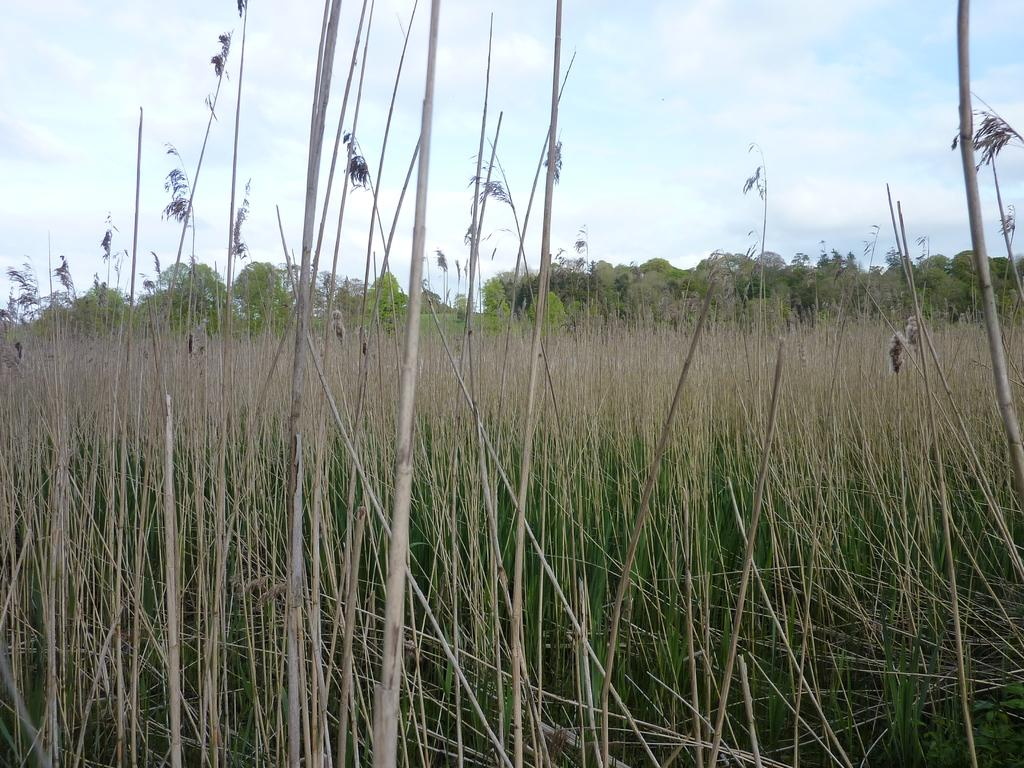What can be seen at the top of the image? The sky is visible towards the top of the image. What is present in the sky? There are clouds in the sky. What type of vegetation is present in the image? There are trees and plants in the image. Where are the plants located in the image? The plants are towards the bottom of the image. Who is the creator of the clouds in the image? The image does not provide information about the creator of the clouds; clouds are a natural weather phenomenon. What type of brick is used to build the trees in the image? There are no bricks present in the image; the trees are made of natural materials such as wood and leaves. 